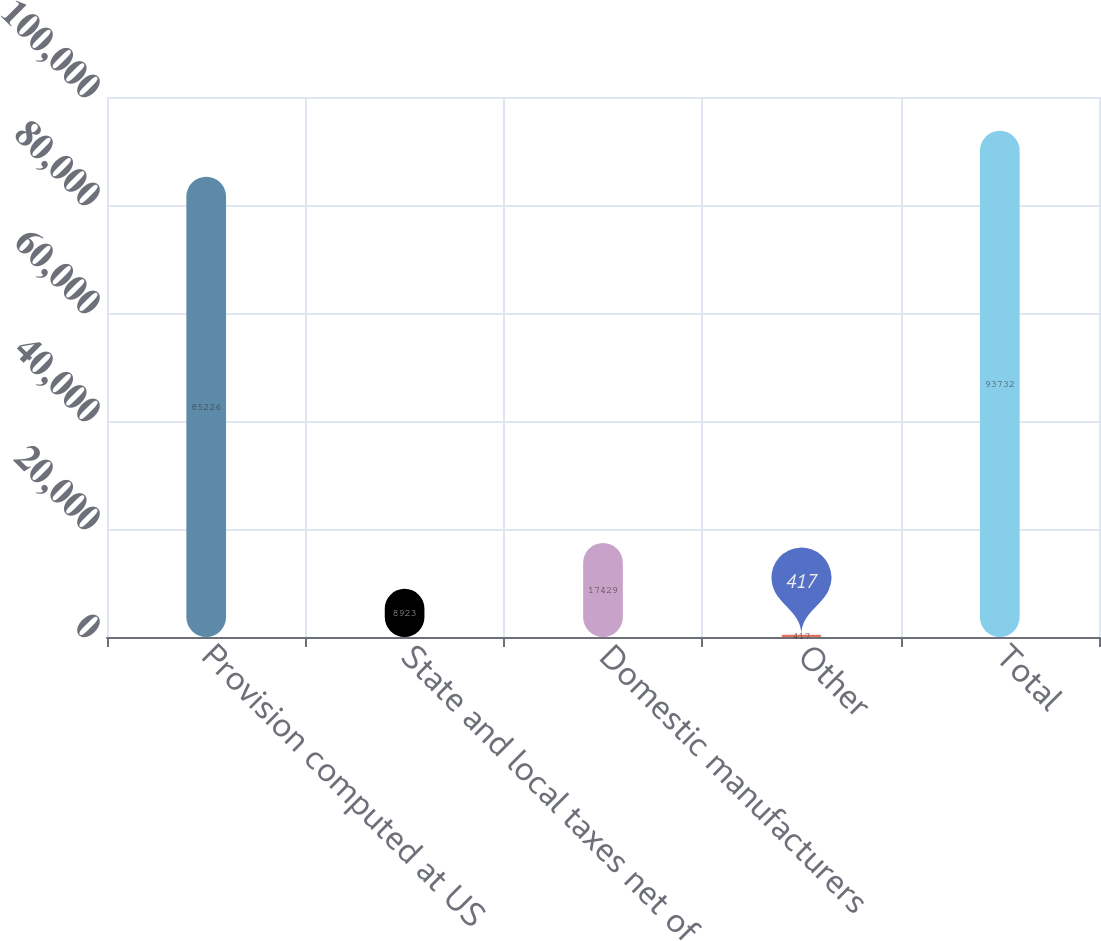<chart> <loc_0><loc_0><loc_500><loc_500><bar_chart><fcel>Provision computed at US<fcel>State and local taxes net of<fcel>Domestic manufacturers<fcel>Other<fcel>Total<nl><fcel>85226<fcel>8923<fcel>17429<fcel>417<fcel>93732<nl></chart> 